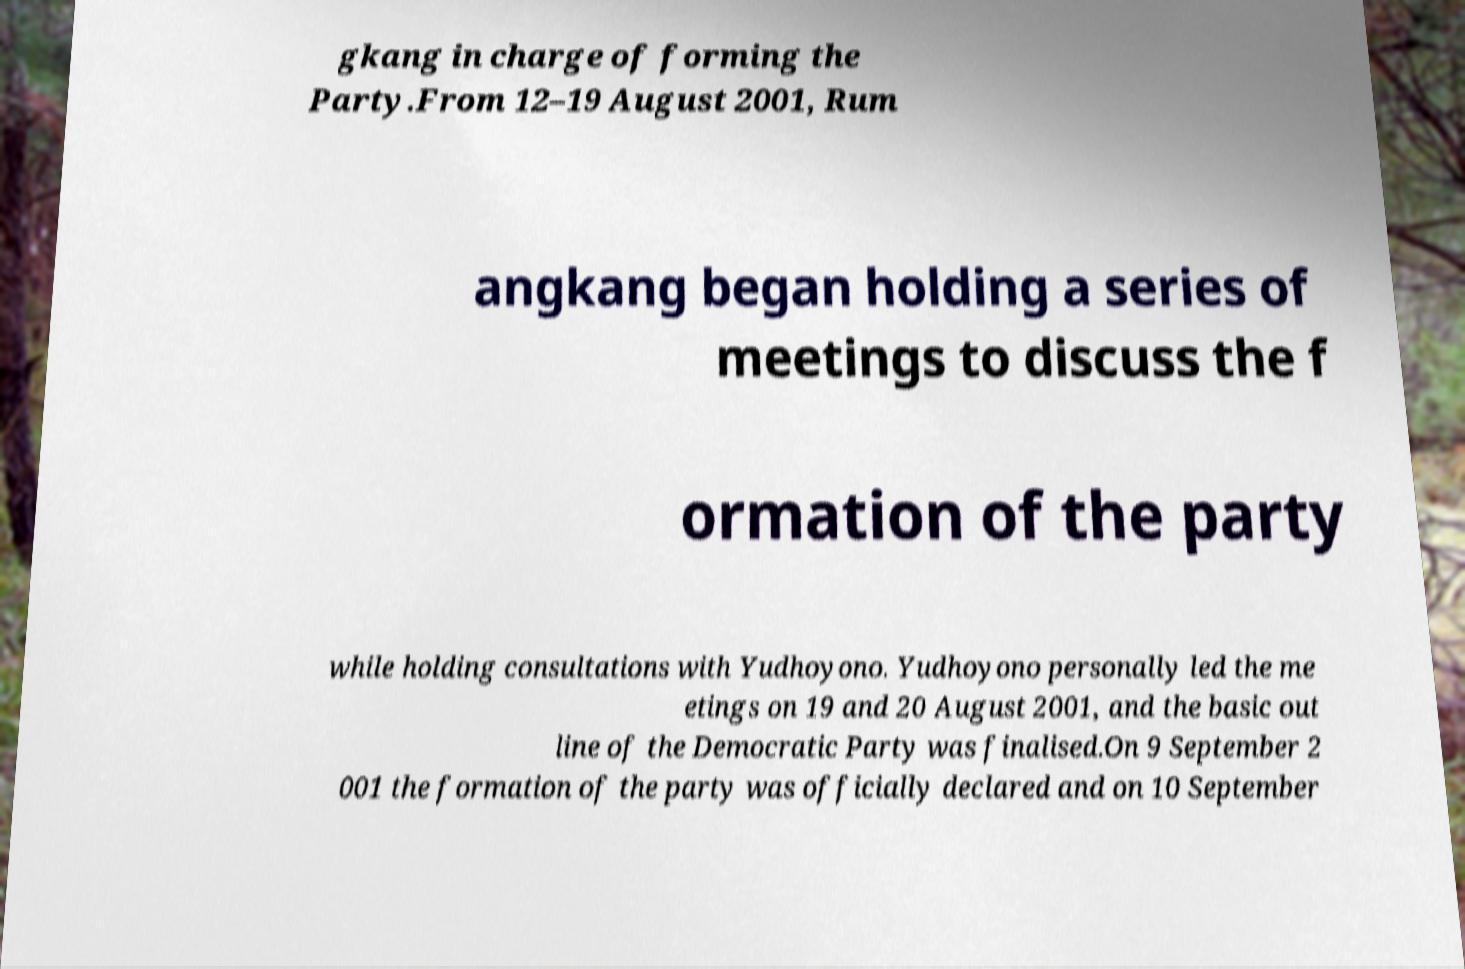Could you assist in decoding the text presented in this image and type it out clearly? gkang in charge of forming the Party.From 12–19 August 2001, Rum angkang began holding a series of meetings to discuss the f ormation of the party while holding consultations with Yudhoyono. Yudhoyono personally led the me etings on 19 and 20 August 2001, and the basic out line of the Democratic Party was finalised.On 9 September 2 001 the formation of the party was officially declared and on 10 September 